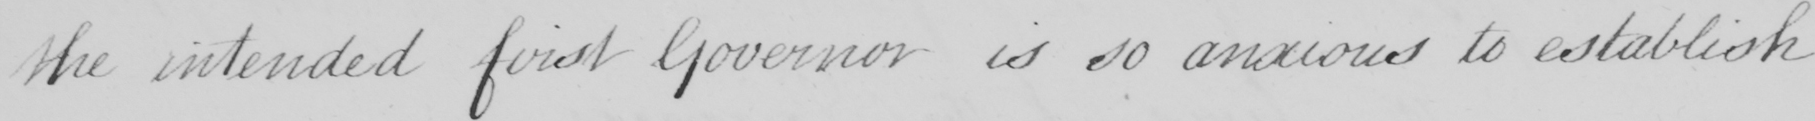What does this handwritten line say? the intended first Governor is so anxious to establish 